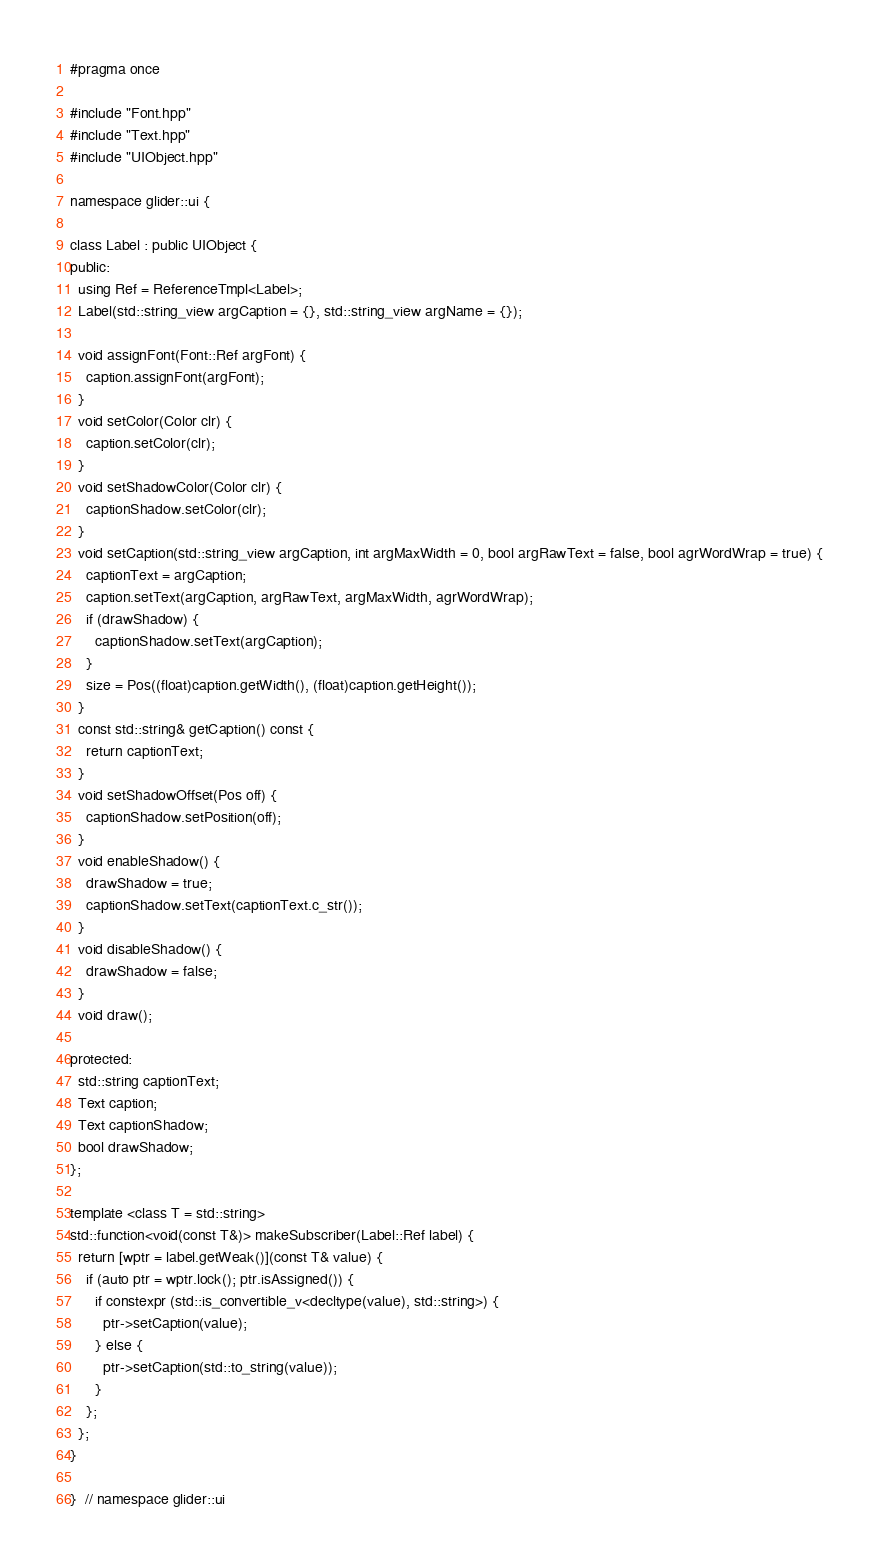Convert code to text. <code><loc_0><loc_0><loc_500><loc_500><_C++_>#pragma once

#include "Font.hpp"
#include "Text.hpp"
#include "UIObject.hpp"

namespace glider::ui {

class Label : public UIObject {
public:
  using Ref = ReferenceTmpl<Label>;
  Label(std::string_view argCaption = {}, std::string_view argName = {});

  void assignFont(Font::Ref argFont) {
    caption.assignFont(argFont);
  }
  void setColor(Color clr) {
    caption.setColor(clr);
  }
  void setShadowColor(Color clr) {
    captionShadow.setColor(clr);
  }
  void setCaption(std::string_view argCaption, int argMaxWidth = 0, bool argRawText = false, bool agrWordWrap = true) {
    captionText = argCaption;
    caption.setText(argCaption, argRawText, argMaxWidth, agrWordWrap);
    if (drawShadow) {
      captionShadow.setText(argCaption);
    }
    size = Pos((float)caption.getWidth(), (float)caption.getHeight());
  }
  const std::string& getCaption() const {
    return captionText;
  }
  void setShadowOffset(Pos off) {
    captionShadow.setPosition(off);
  }
  void enableShadow() {
    drawShadow = true;
    captionShadow.setText(captionText.c_str());
  }
  void disableShadow() {
    drawShadow = false;
  }
  void draw();

protected:
  std::string captionText;
  Text caption;
  Text captionShadow;
  bool drawShadow;
};

template <class T = std::string>
std::function<void(const T&)> makeSubscriber(Label::Ref label) {
  return [wptr = label.getWeak()](const T& value) {
    if (auto ptr = wptr.lock(); ptr.isAssigned()) {
      if constexpr (std::is_convertible_v<decltype(value), std::string>) {
        ptr->setCaption(value);
      } else {
        ptr->setCaption(std::to_string(value));
      }
    };
  };
}

}  // namespace glider::ui
</code> 